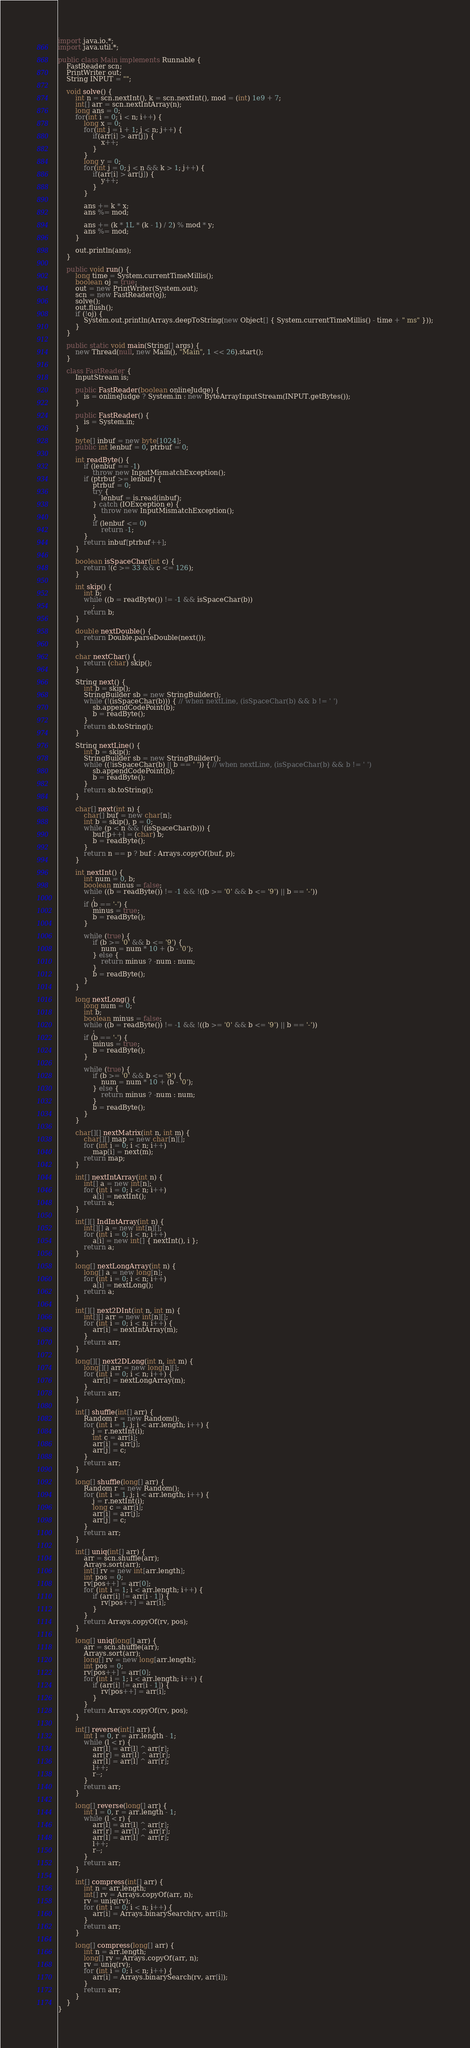Convert code to text. <code><loc_0><loc_0><loc_500><loc_500><_Java_>import java.io.*;
import java.util.*;

public class Main implements Runnable {
	FastReader scn;
	PrintWriter out;
	String INPUT = "";

	void solve() {
		int n = scn.nextInt(), k = scn.nextInt(), mod = (int) 1e9 + 7;
		int[] arr = scn.nextIntArray(n);
		long ans = 0;
		for(int i = 0; i < n; i++) {
			long x = 0;
			for(int j = i + 1; j < n; j++) {
				if(arr[i] > arr[j]) {
					x++;
				}
			}
			long y = 0;
			for(int j = 0; j < n && k > 1; j++) {
				if(arr[i] > arr[j]) {
					y++;
				}
			}
			
			ans += k * x;
			ans %= mod;
			
			ans += (k * 1L * (k - 1) / 2) % mod * y;
			ans %= mod;
		}
		
		out.println(ans);
	}

	public void run() {
		long time = System.currentTimeMillis();
		boolean oj = true;
		out = new PrintWriter(System.out);
		scn = new FastReader(oj);
		solve();
		out.flush();
		if (!oj) {
			System.out.println(Arrays.deepToString(new Object[] { System.currentTimeMillis() - time + " ms" }));
		}
	}

	public static void main(String[] args) {
		new Thread(null, new Main(), "Main", 1 << 26).start();
	}

	class FastReader {
		InputStream is;

		public FastReader(boolean onlineJudge) {
			is = onlineJudge ? System.in : new ByteArrayInputStream(INPUT.getBytes());
		}

		public FastReader() {
			is = System.in;
		}

		byte[] inbuf = new byte[1024];
		public int lenbuf = 0, ptrbuf = 0;

		int readByte() {
			if (lenbuf == -1)
				throw new InputMismatchException();
			if (ptrbuf >= lenbuf) {
				ptrbuf = 0;
				try {
					lenbuf = is.read(inbuf);
				} catch (IOException e) {
					throw new InputMismatchException();
				}
				if (lenbuf <= 0)
					return -1;
			}
			return inbuf[ptrbuf++];
		}

		boolean isSpaceChar(int c) {
			return !(c >= 33 && c <= 126);
		}

		int skip() {
			int b;
			while ((b = readByte()) != -1 && isSpaceChar(b))
				;
			return b;
		}

		double nextDouble() {
			return Double.parseDouble(next());
		}

		char nextChar() {
			return (char) skip();
		}

		String next() {
			int b = skip();
			StringBuilder sb = new StringBuilder();
			while (!(isSpaceChar(b))) { // when nextLine, (isSpaceChar(b) && b != ' ')
				sb.appendCodePoint(b);
				b = readByte();
			}
			return sb.toString();
		}

		String nextLine() {
			int b = skip();
			StringBuilder sb = new StringBuilder();
			while ((!isSpaceChar(b) || b == ' ')) { // when nextLine, (isSpaceChar(b) && b != ' ')
				sb.appendCodePoint(b);
				b = readByte();
			}
			return sb.toString();
		}

		char[] next(int n) {
			char[] buf = new char[n];
			int b = skip(), p = 0;
			while (p < n && !(isSpaceChar(b))) {
				buf[p++] = (char) b;
				b = readByte();
			}
			return n == p ? buf : Arrays.copyOf(buf, p);
		}

		int nextInt() {
			int num = 0, b;
			boolean minus = false;
			while ((b = readByte()) != -1 && !((b >= '0' && b <= '9') || b == '-'))
				;
			if (b == '-') {
				minus = true;
				b = readByte();
			}

			while (true) {
				if (b >= '0' && b <= '9') {
					num = num * 10 + (b - '0');
				} else {
					return minus ? -num : num;
				}
				b = readByte();
			}
		}

		long nextLong() {
			long num = 0;
			int b;
			boolean minus = false;
			while ((b = readByte()) != -1 && !((b >= '0' && b <= '9') || b == '-'))
				;
			if (b == '-') {
				minus = true;
				b = readByte();
			}

			while (true) {
				if (b >= '0' && b <= '9') {
					num = num * 10 + (b - '0');
				} else {
					return minus ? -num : num;
				}
				b = readByte();
			}
		}

		char[][] nextMatrix(int n, int m) {
			char[][] map = new char[n][];
			for (int i = 0; i < n; i++)
				map[i] = next(m);
			return map;
		}

		int[] nextIntArray(int n) {
			int[] a = new int[n];
			for (int i = 0; i < n; i++)
				a[i] = nextInt();
			return a;
		}

		int[][] IndIntArray(int n) {
			int[][] a = new int[n][];
			for (int i = 0; i < n; i++)
				a[i] = new int[] { nextInt(), i };
			return a;
		}

		long[] nextLongArray(int n) {
			long[] a = new long[n];
			for (int i = 0; i < n; i++)
				a[i] = nextLong();
			return a;
		}

		int[][] next2DInt(int n, int m) {
			int[][] arr = new int[n][];
			for (int i = 0; i < n; i++) {
				arr[i] = nextIntArray(m);
			}
			return arr;
		}

		long[][] next2DLong(int n, int m) {
			long[][] arr = new long[n][];
			for (int i = 0; i < n; i++) {
				arr[i] = nextLongArray(m);
			}
			return arr;
		}

		int[] shuffle(int[] arr) {
			Random r = new Random();
			for (int i = 1, j; i < arr.length; i++) {
				j = r.nextInt(i);
				int c = arr[i];
				arr[i] = arr[j];
				arr[j] = c;
			}
			return arr;
		}

		long[] shuffle(long[] arr) {
			Random r = new Random();
			for (int i = 1, j; i < arr.length; i++) {
				j = r.nextInt(i);
				long c = arr[i];
				arr[i] = arr[j];
				arr[j] = c;
			}
			return arr;
		}

		int[] uniq(int[] arr) {
			arr = scn.shuffle(arr);
			Arrays.sort(arr);
			int[] rv = new int[arr.length];
			int pos = 0;
			rv[pos++] = arr[0];
			for (int i = 1; i < arr.length; i++) {
				if (arr[i] != arr[i - 1]) {
					rv[pos++] = arr[i];
				}
			}
			return Arrays.copyOf(rv, pos);
		}

		long[] uniq(long[] arr) {
			arr = scn.shuffle(arr);
			Arrays.sort(arr);
			long[] rv = new long[arr.length];
			int pos = 0;
			rv[pos++] = arr[0];
			for (int i = 1; i < arr.length; i++) {
				if (arr[i] != arr[i - 1]) {
					rv[pos++] = arr[i];
				}
			}
			return Arrays.copyOf(rv, pos);
		}

		int[] reverse(int[] arr) {
			int l = 0, r = arr.length - 1;
			while (l < r) {
				arr[l] = arr[l] ^ arr[r];
				arr[r] = arr[l] ^ arr[r];
				arr[l] = arr[l] ^ arr[r];
				l++;
				r--;
			}
			return arr;
		}

		long[] reverse(long[] arr) {
			int l = 0, r = arr.length - 1;
			while (l < r) {
				arr[l] = arr[l] ^ arr[r];
				arr[r] = arr[l] ^ arr[r];
				arr[l] = arr[l] ^ arr[r];
				l++;
				r--;
			}
			return arr;
		}

		int[] compress(int[] arr) {
			int n = arr.length;
			int[] rv = Arrays.copyOf(arr, n);
			rv = uniq(rv);
			for (int i = 0; i < n; i++) {
				arr[i] = Arrays.binarySearch(rv, arr[i]);
			}
			return arr;
		}

		long[] compress(long[] arr) {
			int n = arr.length;
			long[] rv = Arrays.copyOf(arr, n);
			rv = uniq(rv);
			for (int i = 0; i < n; i++) {
				arr[i] = Arrays.binarySearch(rv, arr[i]);
			}
			return arr;
		}
	}
}</code> 